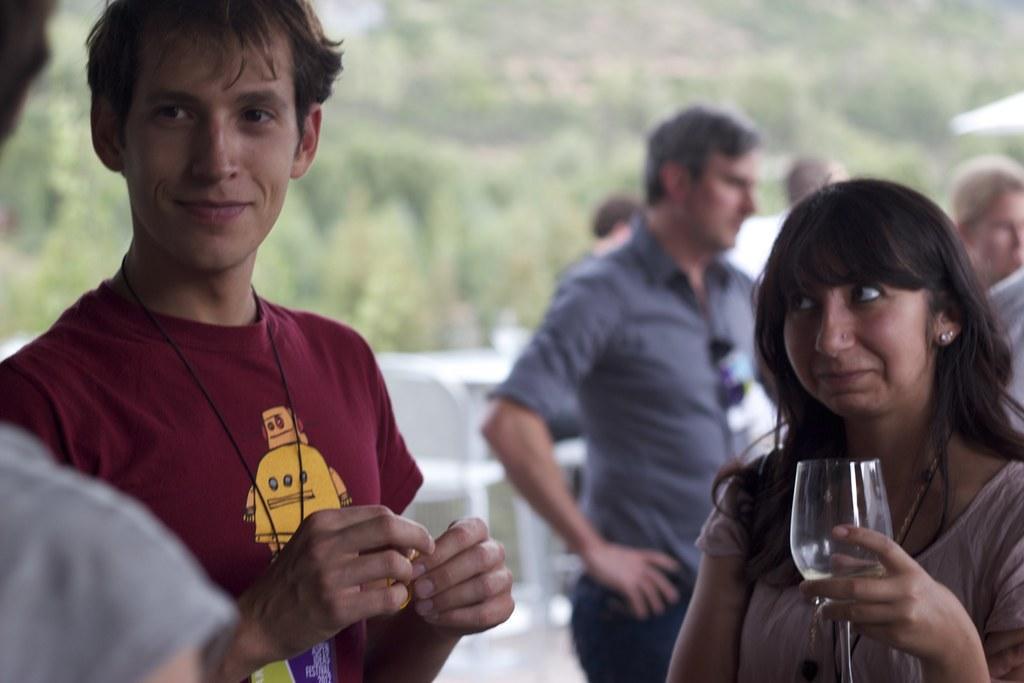Please provide a concise description of this image. In this image we can see a few people, among them, some are holding the objects and in the background, we can see some trees. 